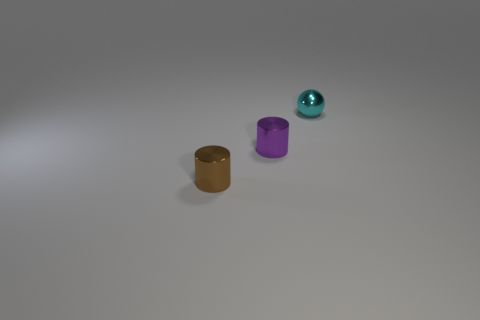Add 1 small blue cubes. How many objects exist? 4 Subtract all brown cylinders. How many cylinders are left? 1 Subtract all green spheres. How many red cylinders are left? 0 Subtract all small purple cylinders. Subtract all small purple cylinders. How many objects are left? 1 Add 1 cyan metallic spheres. How many cyan metallic spheres are left? 2 Add 1 purple objects. How many purple objects exist? 2 Subtract 0 yellow cubes. How many objects are left? 3 Subtract all cylinders. How many objects are left? 1 Subtract all yellow cylinders. Subtract all cyan spheres. How many cylinders are left? 2 